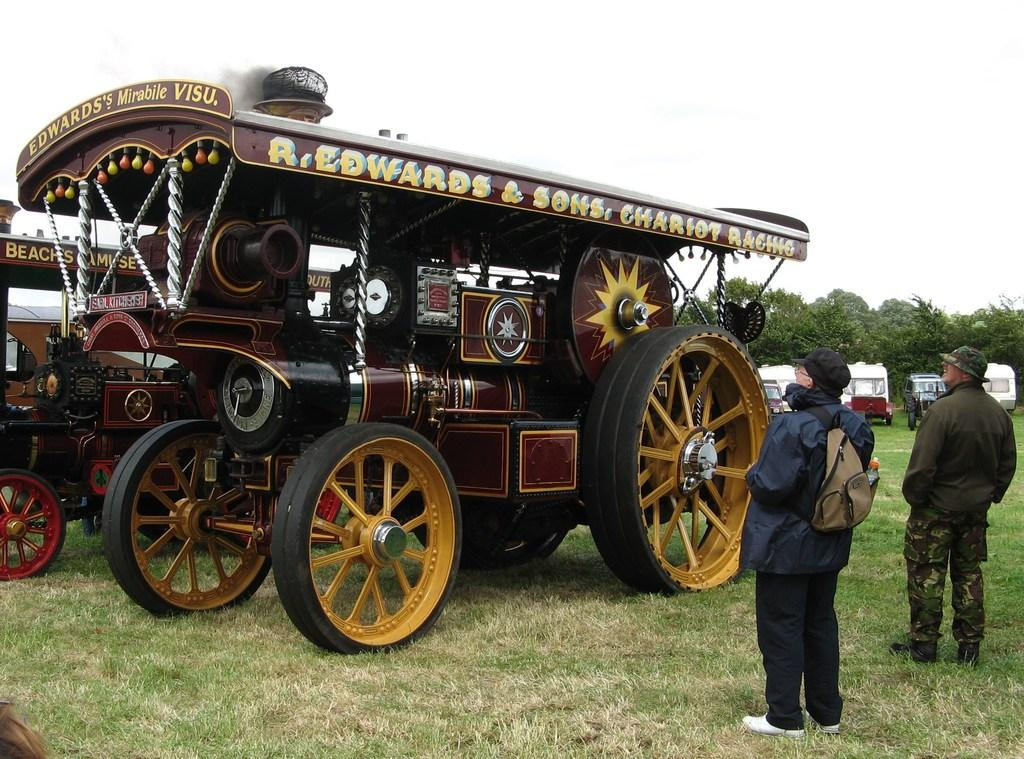What is the setting of the image? There are people standing on a grassland in the image. What can be seen in the background of the image? There are vehicles and trees in the background of the image, as well as the sky. Is there a lake visible in the image? No, there is no lake present in the image. 